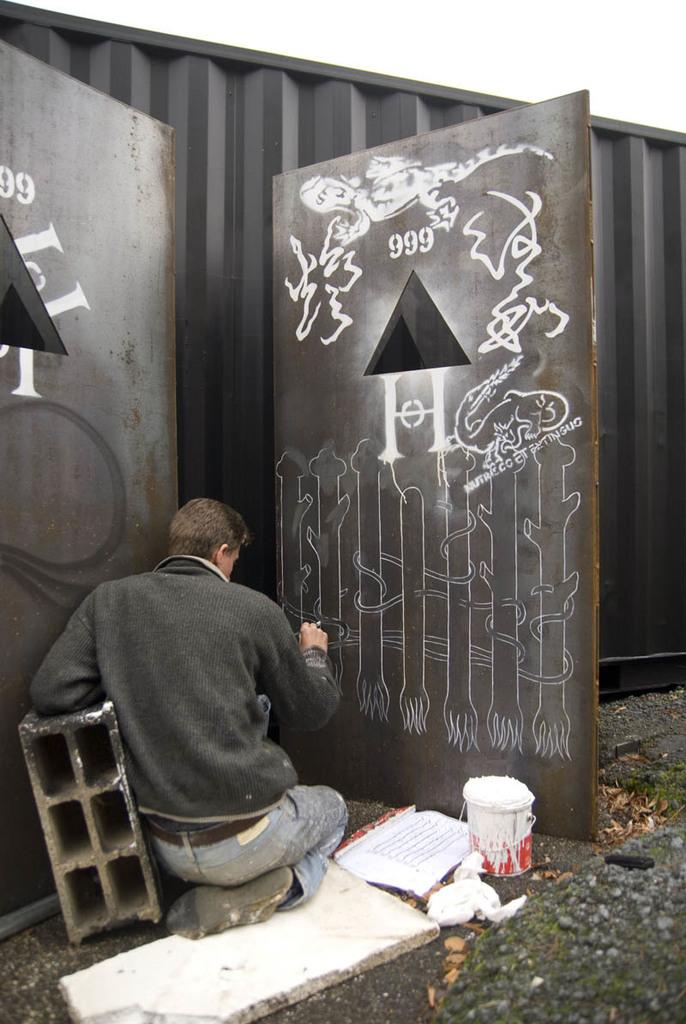What is the person in the image doing? The person is sitting on the floor and painting on a door. What is the person using to paint? The paint bucket in the background of the image suggests that the person is using paint from that bucket. What type of material can be seen in the background of the image? Wooden boards are present in the background of the image. What else is visible in the background of the image? Shredded leaves are present in the background of the image. What type of square object is being used to store the chicken in the image? There is no square object or chicken present in the image. 